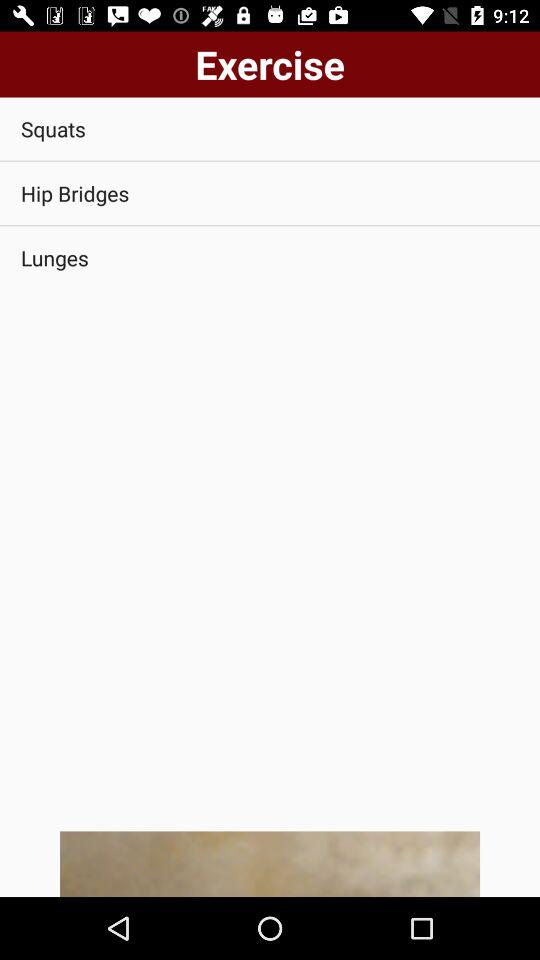What are the names of the exercises shown in the application? The names of the exercises are "Squats", "Hip Bridges" and "Lunges". 